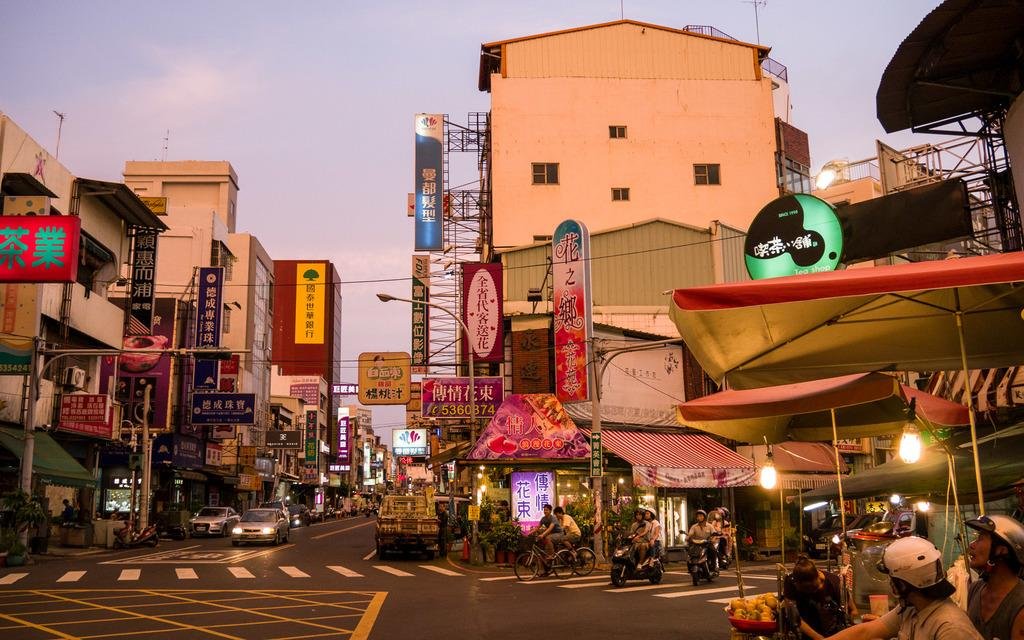What type of structures can be seen in the image? There are buildings with windows in the image. What are the vertical structures with lights on top? Light poles are visible in the image. What type of transportation is present in the image? Vehicles are present in the image. Are there any people visible in the image? Yes, people are in the image. What type of small storage structures can be seen in the image? There are sheds in the image. What are the boards with text used for in the image? The boards with text are in the image. What part of the natural environment is visible in the image? The sky is visible in the image. How many spots can be seen on the yoke in the image? There is no yoke present in the image, and therefore no spots can be observed. 